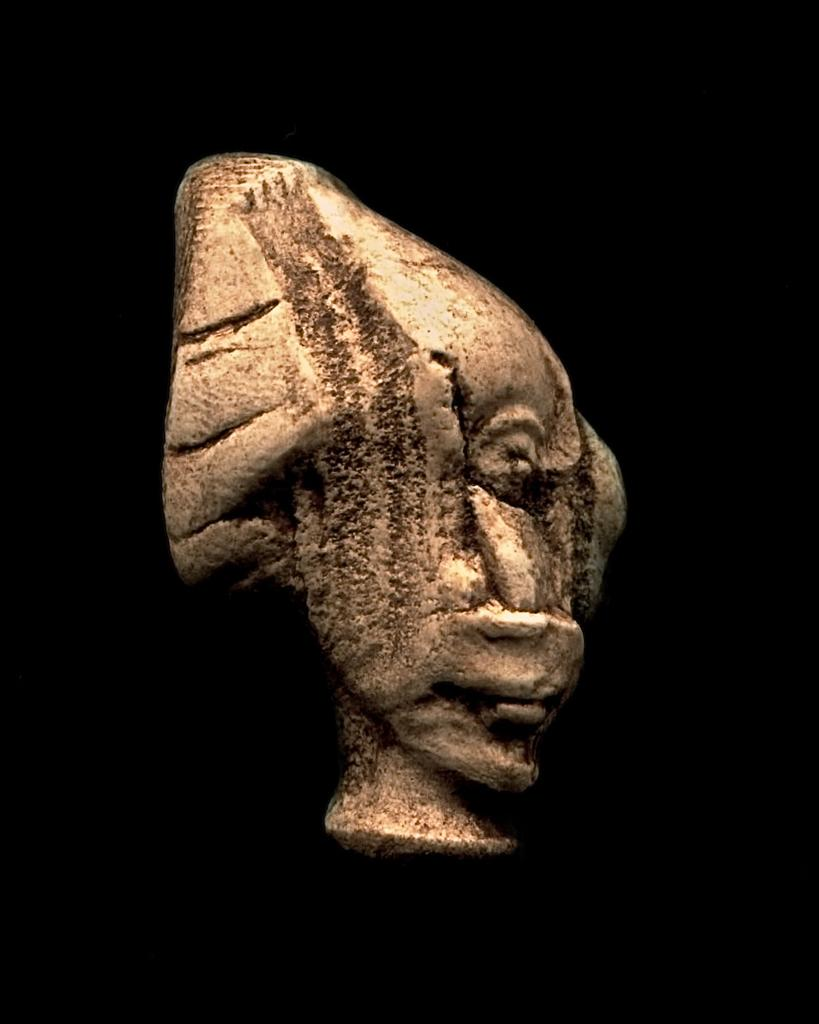What is the main subject of the image? There is a sculpture in the image. What can be seen in the background of the image? The background of the image is black. Can you tell me how many birds are perched on the twig in the image? There is no twig or bird present in the image; it features a sculpture with a black background. 